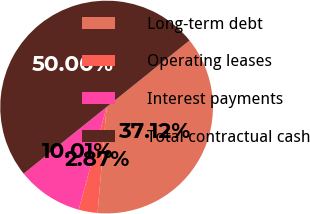Convert chart. <chart><loc_0><loc_0><loc_500><loc_500><pie_chart><fcel>Long-term debt<fcel>Operating leases<fcel>Interest payments<fcel>Total contractual cash<nl><fcel>37.12%<fcel>2.87%<fcel>10.01%<fcel>50.0%<nl></chart> 